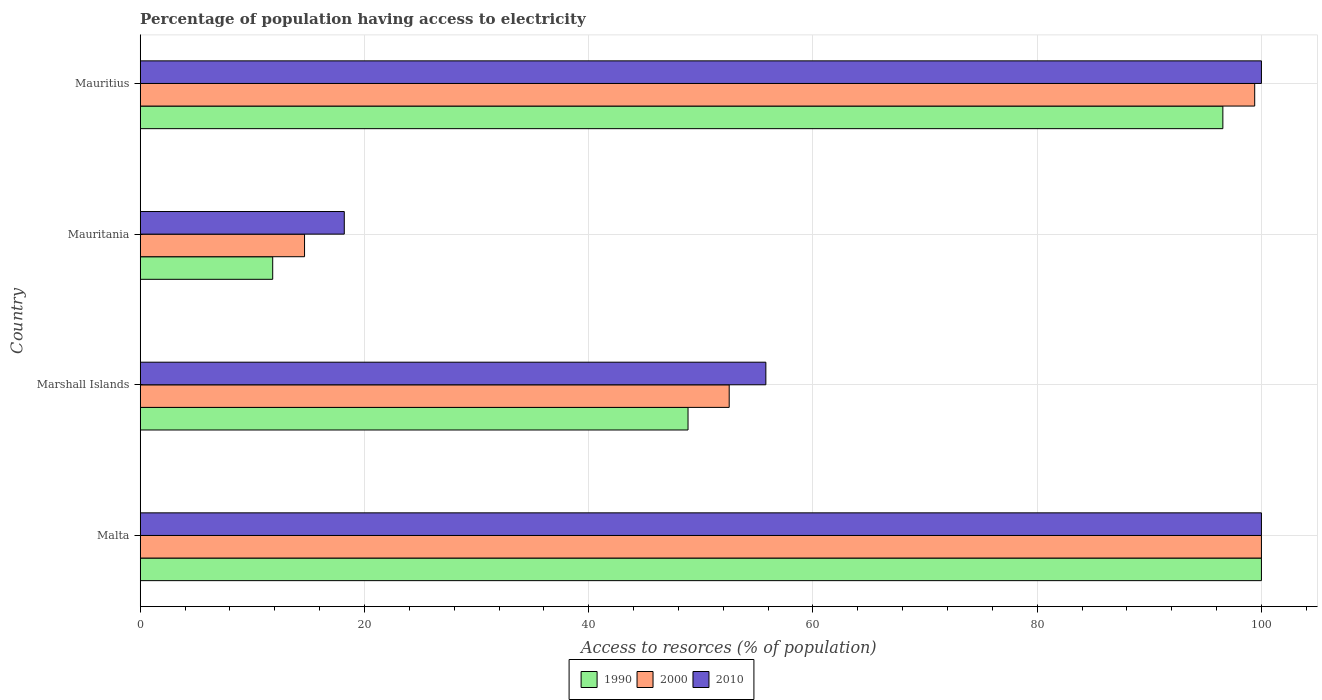How many bars are there on the 4th tick from the bottom?
Ensure brevity in your answer.  3. What is the label of the 3rd group of bars from the top?
Offer a very short reply. Marshall Islands. In how many cases, is the number of bars for a given country not equal to the number of legend labels?
Ensure brevity in your answer.  0. What is the percentage of population having access to electricity in 2010 in Marshall Islands?
Your answer should be very brief. 55.8. Across all countries, what is the maximum percentage of population having access to electricity in 1990?
Your answer should be compact. 100. Across all countries, what is the minimum percentage of population having access to electricity in 2000?
Provide a short and direct response. 14.66. In which country was the percentage of population having access to electricity in 1990 maximum?
Your answer should be very brief. Malta. In which country was the percentage of population having access to electricity in 1990 minimum?
Provide a succinct answer. Mauritania. What is the total percentage of population having access to electricity in 2000 in the graph?
Your answer should be compact. 266.59. What is the difference between the percentage of population having access to electricity in 2010 in Malta and that in Mauritania?
Your response must be concise. 81.8. What is the difference between the percentage of population having access to electricity in 2000 in Mauritania and the percentage of population having access to electricity in 2010 in Malta?
Your response must be concise. -85.34. What is the average percentage of population having access to electricity in 1990 per country?
Ensure brevity in your answer.  64.31. What is the difference between the percentage of population having access to electricity in 1990 and percentage of population having access to electricity in 2010 in Mauritania?
Offer a terse response. -6.38. In how many countries, is the percentage of population having access to electricity in 2010 greater than 20 %?
Give a very brief answer. 3. What is the ratio of the percentage of population having access to electricity in 2000 in Marshall Islands to that in Mauritius?
Ensure brevity in your answer.  0.53. Is the percentage of population having access to electricity in 2010 in Marshall Islands less than that in Mauritania?
Provide a succinct answer. No. What is the difference between the highest and the second highest percentage of population having access to electricity in 1990?
Give a very brief answer. 3.44. What is the difference between the highest and the lowest percentage of population having access to electricity in 2010?
Provide a short and direct response. 81.8. In how many countries, is the percentage of population having access to electricity in 1990 greater than the average percentage of population having access to electricity in 1990 taken over all countries?
Ensure brevity in your answer.  2. What does the 1st bar from the bottom in Malta represents?
Provide a succinct answer. 1990. Is it the case that in every country, the sum of the percentage of population having access to electricity in 1990 and percentage of population having access to electricity in 2000 is greater than the percentage of population having access to electricity in 2010?
Offer a terse response. Yes. How many bars are there?
Your response must be concise. 12. How are the legend labels stacked?
Keep it short and to the point. Horizontal. What is the title of the graph?
Offer a very short reply. Percentage of population having access to electricity. What is the label or title of the X-axis?
Offer a terse response. Access to resorces (% of population). What is the label or title of the Y-axis?
Provide a succinct answer. Country. What is the Access to resorces (% of population) in 2000 in Malta?
Your response must be concise. 100. What is the Access to resorces (% of population) of 1990 in Marshall Islands?
Your answer should be compact. 48.86. What is the Access to resorces (% of population) in 2000 in Marshall Islands?
Your response must be concise. 52.53. What is the Access to resorces (% of population) of 2010 in Marshall Islands?
Your response must be concise. 55.8. What is the Access to resorces (% of population) in 1990 in Mauritania?
Provide a short and direct response. 11.82. What is the Access to resorces (% of population) of 2000 in Mauritania?
Give a very brief answer. 14.66. What is the Access to resorces (% of population) of 2010 in Mauritania?
Your answer should be very brief. 18.2. What is the Access to resorces (% of population) of 1990 in Mauritius?
Ensure brevity in your answer.  96.56. What is the Access to resorces (% of population) in 2000 in Mauritius?
Your answer should be compact. 99.4. Across all countries, what is the maximum Access to resorces (% of population) in 1990?
Your response must be concise. 100. Across all countries, what is the maximum Access to resorces (% of population) of 2000?
Offer a very short reply. 100. Across all countries, what is the maximum Access to resorces (% of population) of 2010?
Keep it short and to the point. 100. Across all countries, what is the minimum Access to resorces (% of population) of 1990?
Your answer should be compact. 11.82. Across all countries, what is the minimum Access to resorces (% of population) of 2000?
Your response must be concise. 14.66. Across all countries, what is the minimum Access to resorces (% of population) of 2010?
Your response must be concise. 18.2. What is the total Access to resorces (% of population) in 1990 in the graph?
Your answer should be compact. 257.23. What is the total Access to resorces (% of population) in 2000 in the graph?
Provide a short and direct response. 266.59. What is the total Access to resorces (% of population) in 2010 in the graph?
Your answer should be very brief. 274. What is the difference between the Access to resorces (% of population) of 1990 in Malta and that in Marshall Islands?
Ensure brevity in your answer.  51.14. What is the difference between the Access to resorces (% of population) of 2000 in Malta and that in Marshall Islands?
Give a very brief answer. 47.47. What is the difference between the Access to resorces (% of population) in 2010 in Malta and that in Marshall Islands?
Provide a short and direct response. 44.2. What is the difference between the Access to resorces (% of population) of 1990 in Malta and that in Mauritania?
Provide a short and direct response. 88.18. What is the difference between the Access to resorces (% of population) of 2000 in Malta and that in Mauritania?
Ensure brevity in your answer.  85.34. What is the difference between the Access to resorces (% of population) of 2010 in Malta and that in Mauritania?
Your response must be concise. 81.8. What is the difference between the Access to resorces (% of population) in 1990 in Malta and that in Mauritius?
Keep it short and to the point. 3.44. What is the difference between the Access to resorces (% of population) in 2000 in Malta and that in Mauritius?
Give a very brief answer. 0.6. What is the difference between the Access to resorces (% of population) of 2010 in Malta and that in Mauritius?
Ensure brevity in your answer.  0. What is the difference between the Access to resorces (% of population) of 1990 in Marshall Islands and that in Mauritania?
Offer a very short reply. 37.04. What is the difference between the Access to resorces (% of population) of 2000 in Marshall Islands and that in Mauritania?
Offer a very short reply. 37.87. What is the difference between the Access to resorces (% of population) of 2010 in Marshall Islands and that in Mauritania?
Your response must be concise. 37.6. What is the difference between the Access to resorces (% of population) in 1990 in Marshall Islands and that in Mauritius?
Your answer should be compact. -47.7. What is the difference between the Access to resorces (% of population) in 2000 in Marshall Islands and that in Mauritius?
Offer a very short reply. -46.87. What is the difference between the Access to resorces (% of population) of 2010 in Marshall Islands and that in Mauritius?
Provide a short and direct response. -44.2. What is the difference between the Access to resorces (% of population) in 1990 in Mauritania and that in Mauritius?
Your answer should be very brief. -84.74. What is the difference between the Access to resorces (% of population) of 2000 in Mauritania and that in Mauritius?
Make the answer very short. -84.74. What is the difference between the Access to resorces (% of population) in 2010 in Mauritania and that in Mauritius?
Provide a short and direct response. -81.8. What is the difference between the Access to resorces (% of population) in 1990 in Malta and the Access to resorces (% of population) in 2000 in Marshall Islands?
Offer a terse response. 47.47. What is the difference between the Access to resorces (% of population) of 1990 in Malta and the Access to resorces (% of population) of 2010 in Marshall Islands?
Provide a succinct answer. 44.2. What is the difference between the Access to resorces (% of population) in 2000 in Malta and the Access to resorces (% of population) in 2010 in Marshall Islands?
Keep it short and to the point. 44.2. What is the difference between the Access to resorces (% of population) of 1990 in Malta and the Access to resorces (% of population) of 2000 in Mauritania?
Your response must be concise. 85.34. What is the difference between the Access to resorces (% of population) of 1990 in Malta and the Access to resorces (% of population) of 2010 in Mauritania?
Provide a succinct answer. 81.8. What is the difference between the Access to resorces (% of population) of 2000 in Malta and the Access to resorces (% of population) of 2010 in Mauritania?
Provide a short and direct response. 81.8. What is the difference between the Access to resorces (% of population) in 1990 in Malta and the Access to resorces (% of population) in 2010 in Mauritius?
Offer a very short reply. 0. What is the difference between the Access to resorces (% of population) in 2000 in Malta and the Access to resorces (% of population) in 2010 in Mauritius?
Offer a terse response. 0. What is the difference between the Access to resorces (% of population) in 1990 in Marshall Islands and the Access to resorces (% of population) in 2000 in Mauritania?
Keep it short and to the point. 34.2. What is the difference between the Access to resorces (% of population) in 1990 in Marshall Islands and the Access to resorces (% of population) in 2010 in Mauritania?
Make the answer very short. 30.66. What is the difference between the Access to resorces (% of population) of 2000 in Marshall Islands and the Access to resorces (% of population) of 2010 in Mauritania?
Offer a very short reply. 34.33. What is the difference between the Access to resorces (% of population) of 1990 in Marshall Islands and the Access to resorces (% of population) of 2000 in Mauritius?
Give a very brief answer. -50.54. What is the difference between the Access to resorces (% of population) of 1990 in Marshall Islands and the Access to resorces (% of population) of 2010 in Mauritius?
Your answer should be compact. -51.14. What is the difference between the Access to resorces (% of population) of 2000 in Marshall Islands and the Access to resorces (% of population) of 2010 in Mauritius?
Make the answer very short. -47.47. What is the difference between the Access to resorces (% of population) of 1990 in Mauritania and the Access to resorces (% of population) of 2000 in Mauritius?
Your answer should be very brief. -87.58. What is the difference between the Access to resorces (% of population) in 1990 in Mauritania and the Access to resorces (% of population) in 2010 in Mauritius?
Your answer should be compact. -88.18. What is the difference between the Access to resorces (% of population) of 2000 in Mauritania and the Access to resorces (% of population) of 2010 in Mauritius?
Provide a short and direct response. -85.34. What is the average Access to resorces (% of population) in 1990 per country?
Provide a succinct answer. 64.31. What is the average Access to resorces (% of population) of 2000 per country?
Keep it short and to the point. 66.65. What is the average Access to resorces (% of population) of 2010 per country?
Provide a succinct answer. 68.5. What is the difference between the Access to resorces (% of population) of 2000 and Access to resorces (% of population) of 2010 in Malta?
Your answer should be very brief. 0. What is the difference between the Access to resorces (% of population) in 1990 and Access to resorces (% of population) in 2000 in Marshall Islands?
Provide a succinct answer. -3.67. What is the difference between the Access to resorces (% of population) in 1990 and Access to resorces (% of population) in 2010 in Marshall Islands?
Offer a terse response. -6.94. What is the difference between the Access to resorces (% of population) of 2000 and Access to resorces (% of population) of 2010 in Marshall Islands?
Give a very brief answer. -3.27. What is the difference between the Access to resorces (% of population) in 1990 and Access to resorces (% of population) in 2000 in Mauritania?
Make the answer very short. -2.84. What is the difference between the Access to resorces (% of population) of 1990 and Access to resorces (% of population) of 2010 in Mauritania?
Make the answer very short. -6.38. What is the difference between the Access to resorces (% of population) in 2000 and Access to resorces (% of population) in 2010 in Mauritania?
Your answer should be very brief. -3.54. What is the difference between the Access to resorces (% of population) of 1990 and Access to resorces (% of population) of 2000 in Mauritius?
Offer a terse response. -2.84. What is the difference between the Access to resorces (% of population) of 1990 and Access to resorces (% of population) of 2010 in Mauritius?
Provide a short and direct response. -3.44. What is the difference between the Access to resorces (% of population) of 2000 and Access to resorces (% of population) of 2010 in Mauritius?
Offer a terse response. -0.6. What is the ratio of the Access to resorces (% of population) in 1990 in Malta to that in Marshall Islands?
Your response must be concise. 2.05. What is the ratio of the Access to resorces (% of population) of 2000 in Malta to that in Marshall Islands?
Offer a very short reply. 1.9. What is the ratio of the Access to resorces (% of population) of 2010 in Malta to that in Marshall Islands?
Your answer should be very brief. 1.79. What is the ratio of the Access to resorces (% of population) of 1990 in Malta to that in Mauritania?
Offer a terse response. 8.46. What is the ratio of the Access to resorces (% of population) of 2000 in Malta to that in Mauritania?
Provide a succinct answer. 6.82. What is the ratio of the Access to resorces (% of population) of 2010 in Malta to that in Mauritania?
Offer a terse response. 5.49. What is the ratio of the Access to resorces (% of population) of 1990 in Malta to that in Mauritius?
Offer a terse response. 1.04. What is the ratio of the Access to resorces (% of population) in 2010 in Malta to that in Mauritius?
Offer a terse response. 1. What is the ratio of the Access to resorces (% of population) in 1990 in Marshall Islands to that in Mauritania?
Your answer should be compact. 4.14. What is the ratio of the Access to resorces (% of population) in 2000 in Marshall Islands to that in Mauritania?
Offer a terse response. 3.58. What is the ratio of the Access to resorces (% of population) in 2010 in Marshall Islands to that in Mauritania?
Your response must be concise. 3.07. What is the ratio of the Access to resorces (% of population) in 1990 in Marshall Islands to that in Mauritius?
Your answer should be compact. 0.51. What is the ratio of the Access to resorces (% of population) in 2000 in Marshall Islands to that in Mauritius?
Give a very brief answer. 0.53. What is the ratio of the Access to resorces (% of population) of 2010 in Marshall Islands to that in Mauritius?
Offer a very short reply. 0.56. What is the ratio of the Access to resorces (% of population) in 1990 in Mauritania to that in Mauritius?
Keep it short and to the point. 0.12. What is the ratio of the Access to resorces (% of population) of 2000 in Mauritania to that in Mauritius?
Offer a very short reply. 0.15. What is the ratio of the Access to resorces (% of population) in 2010 in Mauritania to that in Mauritius?
Your response must be concise. 0.18. What is the difference between the highest and the second highest Access to resorces (% of population) of 1990?
Make the answer very short. 3.44. What is the difference between the highest and the second highest Access to resorces (% of population) in 2000?
Your answer should be compact. 0.6. What is the difference between the highest and the second highest Access to resorces (% of population) of 2010?
Offer a very short reply. 0. What is the difference between the highest and the lowest Access to resorces (% of population) of 1990?
Ensure brevity in your answer.  88.18. What is the difference between the highest and the lowest Access to resorces (% of population) of 2000?
Your answer should be very brief. 85.34. What is the difference between the highest and the lowest Access to resorces (% of population) of 2010?
Make the answer very short. 81.8. 